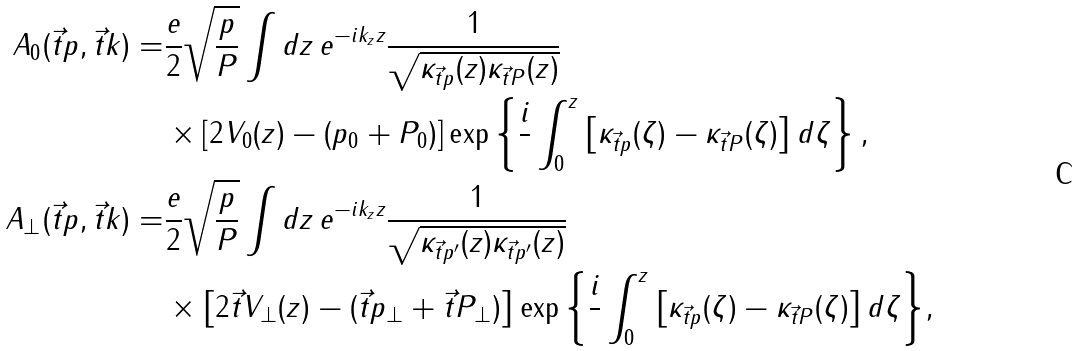<formula> <loc_0><loc_0><loc_500><loc_500>\ A _ { 0 } ( \vec { t } { p } , \vec { t } { k } ) = & \frac { e } { 2 } \sqrt { \frac { p } { P } } \int d z \, e ^ { - i k _ { z } z } \frac { 1 } { \sqrt { \kappa _ { \vec { t } { p } } ( z ) \kappa _ { \vec { t } { P } } ( z ) } } \\ & \times \left [ 2 V _ { 0 } ( z ) - ( p _ { 0 } + P _ { 0 } ) \right ] \exp \left \{ \frac { i } { } \int _ { 0 } ^ { z } \left [ \kappa _ { \vec { t } { p } } ( \zeta ) - \kappa _ { \vec { t } { P } } ( \zeta ) \right ] d \zeta \right \} , \\ \ A _ { \perp } ( \vec { t } { p } , \vec { t } { k } ) = & \frac { e } { 2 } \sqrt { \frac { p } { P } } \int d z \, e ^ { - i k _ { z } z } \frac { 1 } { \sqrt { \kappa _ { \vec { t } { p } ^ { \prime } } ( z ) \kappa _ { \vec { t } { p } ^ { \prime } } ( z ) } } \\ & \times \left [ 2 \vec { t } { V } _ { \perp } ( z ) - ( \vec { t } { p } _ { \perp } + \vec { t } { P } _ { \perp } ) \right ] \exp { \left \{ \frac { i } { } \int _ { 0 } ^ { z } \left [ \kappa _ { \vec { t } { p } } ( \zeta ) - \kappa _ { \vec { t } { P } } ( \zeta ) \right ] d \zeta \right \} } ,</formula> 